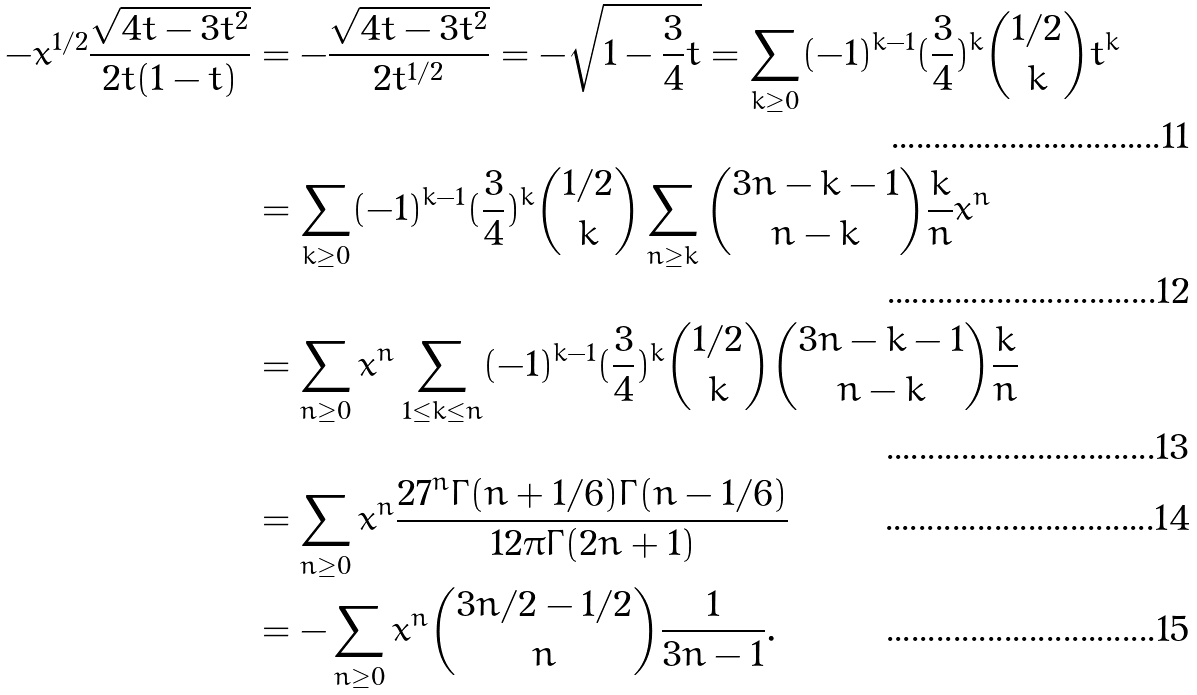Convert formula to latex. <formula><loc_0><loc_0><loc_500><loc_500>- x ^ { 1 / 2 } \frac { \sqrt { 4 t - 3 t ^ { 2 } } } { 2 t ( 1 - t ) } & = - \frac { \sqrt { 4 t - 3 t ^ { 2 } } } { 2 t ^ { 1 / 2 } } = - \sqrt { 1 - \frac { 3 } { 4 } t } = \sum _ { k \geq 0 } ( - 1 ) ^ { k - 1 } ( \frac { 3 } { 4 } ) ^ { k } \binom { 1 / 2 } { k } t ^ { k } \\ & = \sum _ { k \geq 0 } ( - 1 ) ^ { k - 1 } ( \frac { 3 } { 4 } ) ^ { k } \binom { 1 / 2 } { k } \sum _ { n \geq k } \binom { 3 n - k - 1 } { n - k } \frac { k } { n } x ^ { n } \\ & = \sum _ { n \geq 0 } x ^ { n } \sum _ { 1 \leq k \leq n } ( - 1 ) ^ { k - 1 } ( \frac { 3 } { 4 } ) ^ { k } \binom { 1 / 2 } { k } \binom { 3 n - k - 1 } { n - k } \frac { k } { n } \\ & = \sum _ { n \geq 0 } x ^ { n } { \frac { { 2 7 } ^ { n } \Gamma ( n + 1 / 6 ) \Gamma ( n - 1 / 6 ) } { 1 2 \pi \Gamma ( 2 n + 1 ) } } \\ & = - \sum _ { n \geq 0 } x ^ { n } \binom { 3 n / 2 - 1 / 2 } { n } \frac { 1 } { 3 n - 1 } .</formula> 